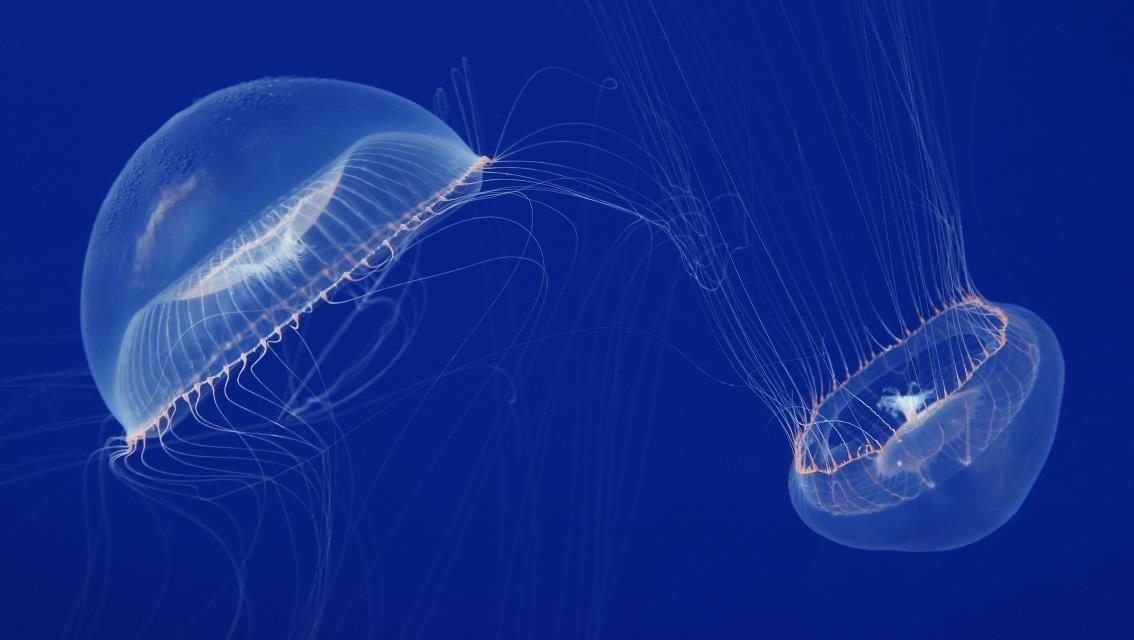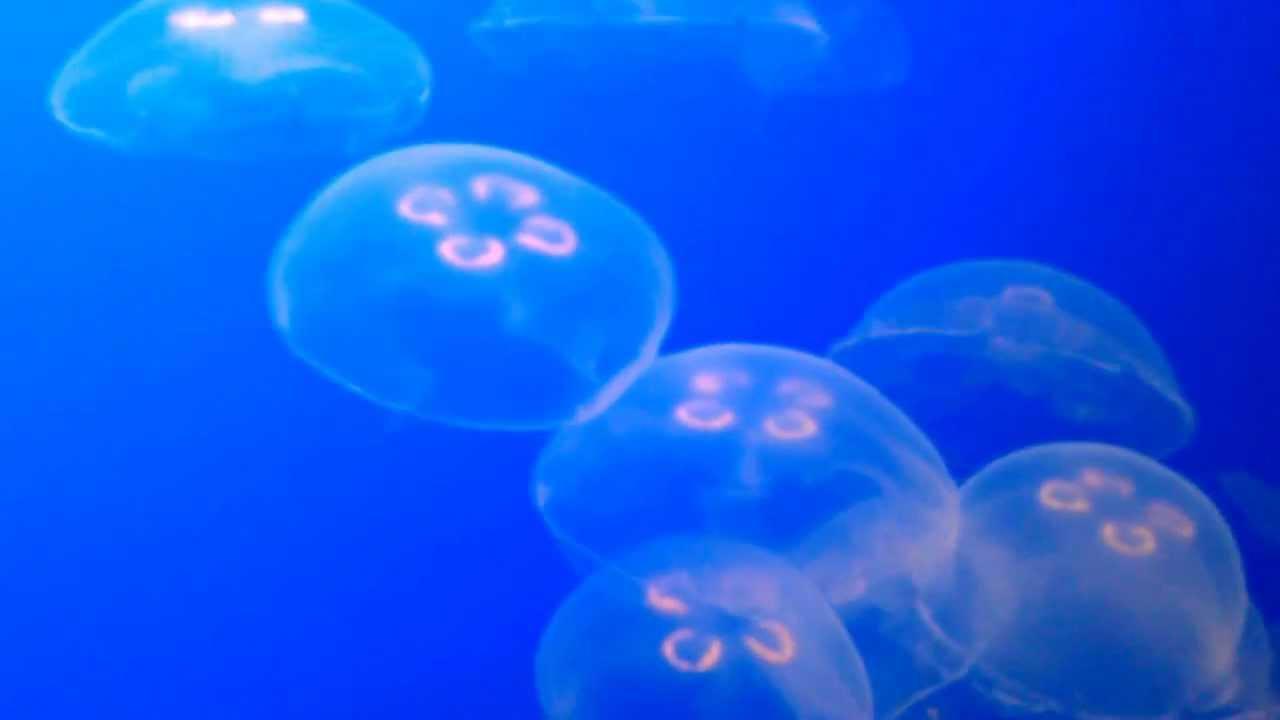The first image is the image on the left, the second image is the image on the right. Given the left and right images, does the statement "There are more than twenty jellyfish." hold true? Answer yes or no. No. The first image is the image on the left, the second image is the image on the right. For the images shown, is this caption "Each image contains at least ten jellyfish, and no jellyfish have thread-like tentacles." true? Answer yes or no. No. 